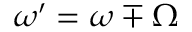<formula> <loc_0><loc_0><loc_500><loc_500>{ \omega ^ { \prime } = \omega \mp \Omega }</formula> 